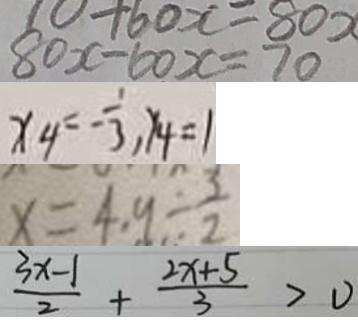<formula> <loc_0><loc_0><loc_500><loc_500>8 0 x - 6 0 x = 7 0 
 x _ { 4 } = - \frac { 1 } { 3 } , y _ { 4 } = 1 
 x = 4 . 9 \div \frac { 3 } { 2 } 
 \frac { 3 x - 1 } { 2 } + \frac { 2 x + 5 } { 3 } > 0</formula> 